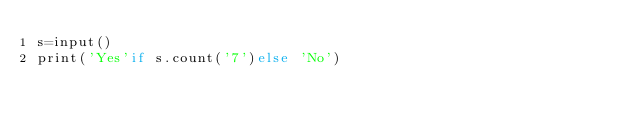Convert code to text. <code><loc_0><loc_0><loc_500><loc_500><_Cython_>s=input()
print('Yes'if s.count('7')else 'No')</code> 